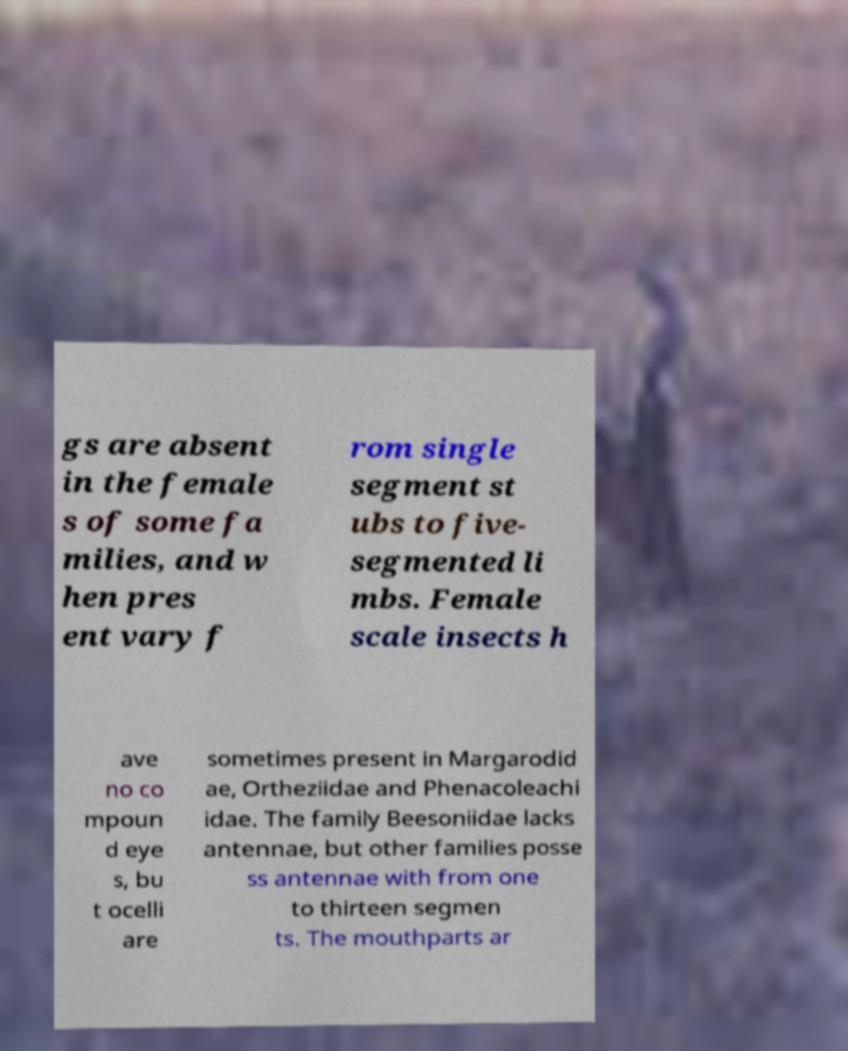What messages or text are displayed in this image? I need them in a readable, typed format. gs are absent in the female s of some fa milies, and w hen pres ent vary f rom single segment st ubs to five- segmented li mbs. Female scale insects h ave no co mpoun d eye s, bu t ocelli are sometimes present in Margarodid ae, Ortheziidae and Phenacoleachi idae. The family Beesoniidae lacks antennae, but other families posse ss antennae with from one to thirteen segmen ts. The mouthparts ar 